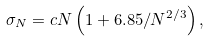<formula> <loc_0><loc_0><loc_500><loc_500>\sigma _ { N } = c N \left ( 1 + 6 . 8 5 / N ^ { 2 / 3 } \right ) ,</formula> 